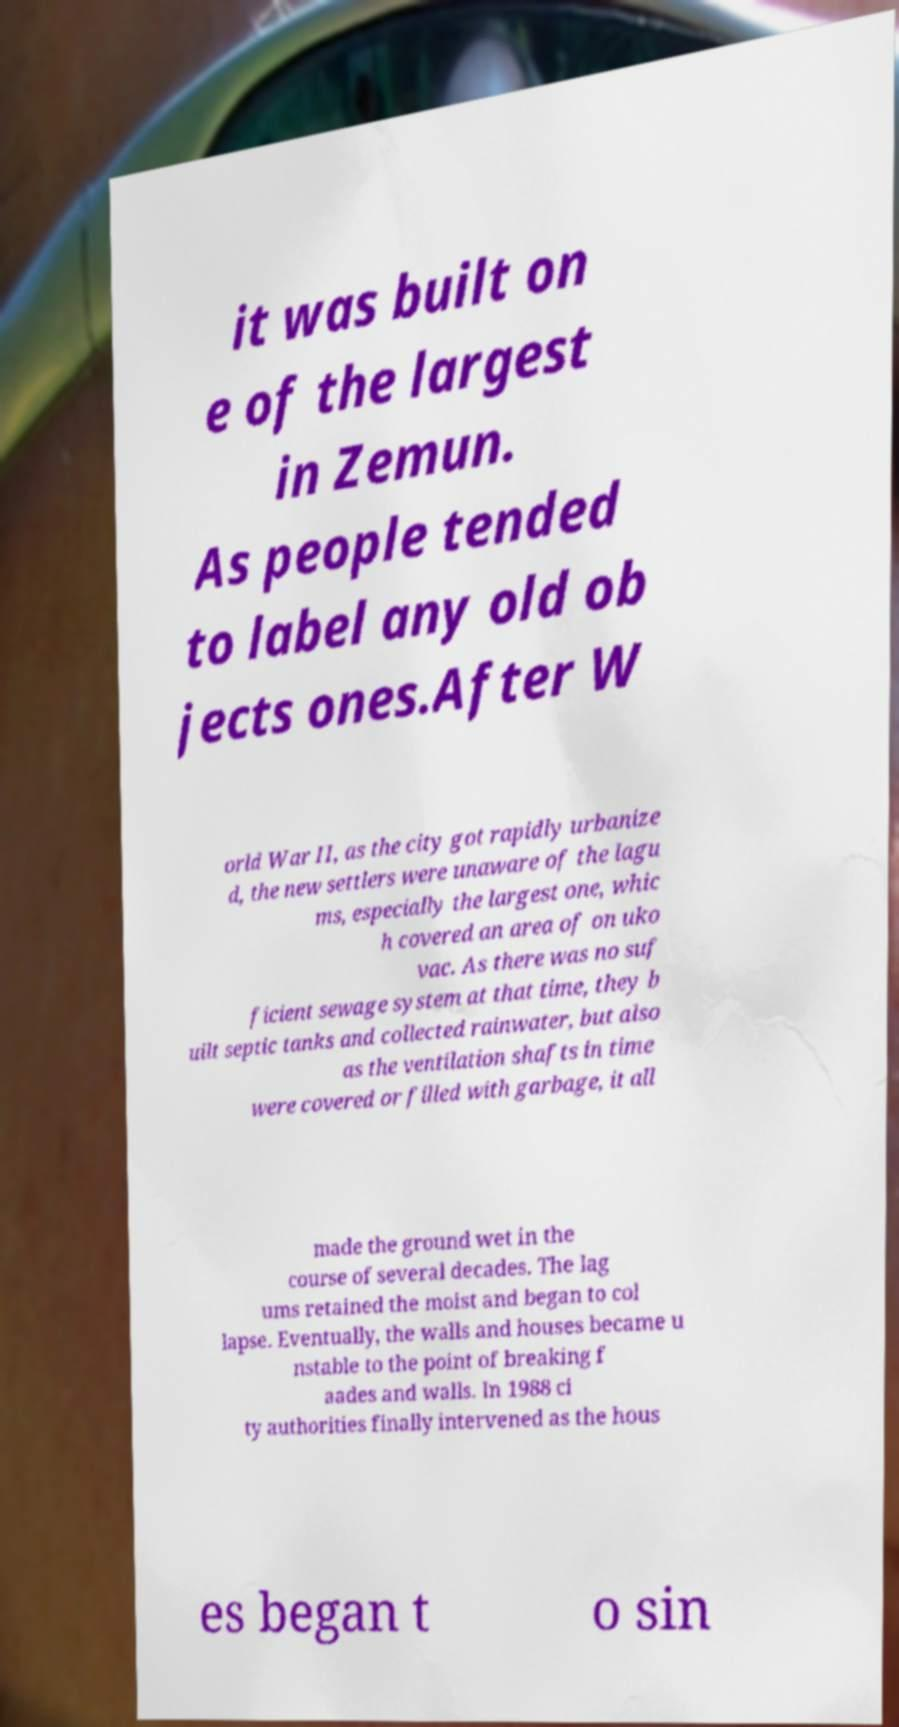Can you accurately transcribe the text from the provided image for me? it was built on e of the largest in Zemun. As people tended to label any old ob jects ones.After W orld War II, as the city got rapidly urbanize d, the new settlers were unaware of the lagu ms, especially the largest one, whic h covered an area of on uko vac. As there was no suf ficient sewage system at that time, they b uilt septic tanks and collected rainwater, but also as the ventilation shafts in time were covered or filled with garbage, it all made the ground wet in the course of several decades. The lag ums retained the moist and began to col lapse. Eventually, the walls and houses became u nstable to the point of breaking f aades and walls. In 1988 ci ty authorities finally intervened as the hous es began t o sin 